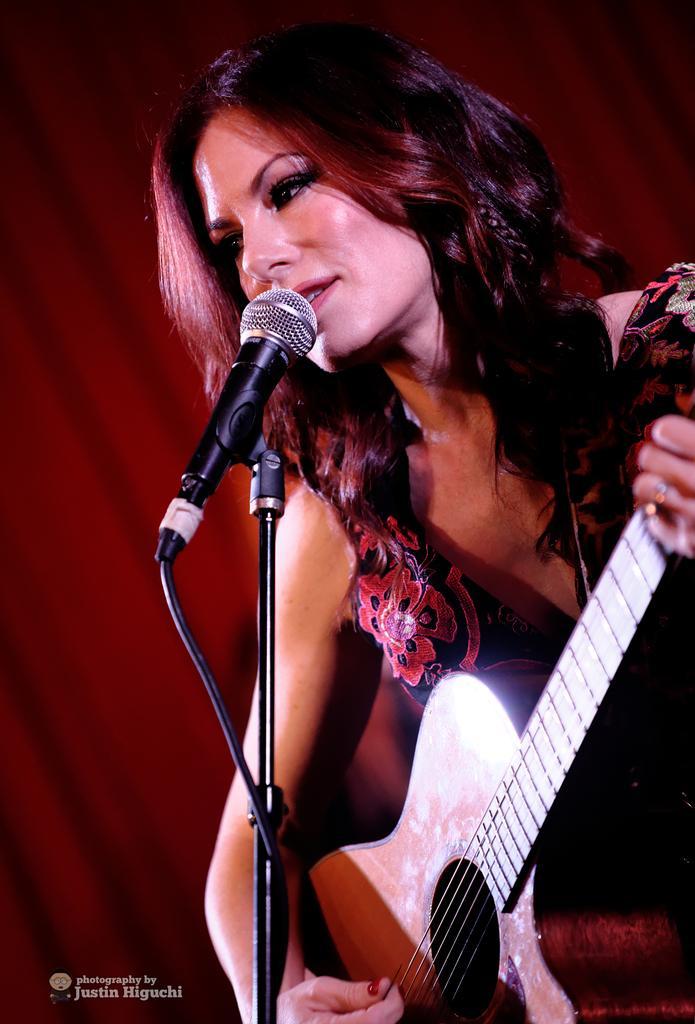Could you give a brief overview of what you see in this image? As we can see in the image there is a woman holding guitar and in front of her there is a mic. 